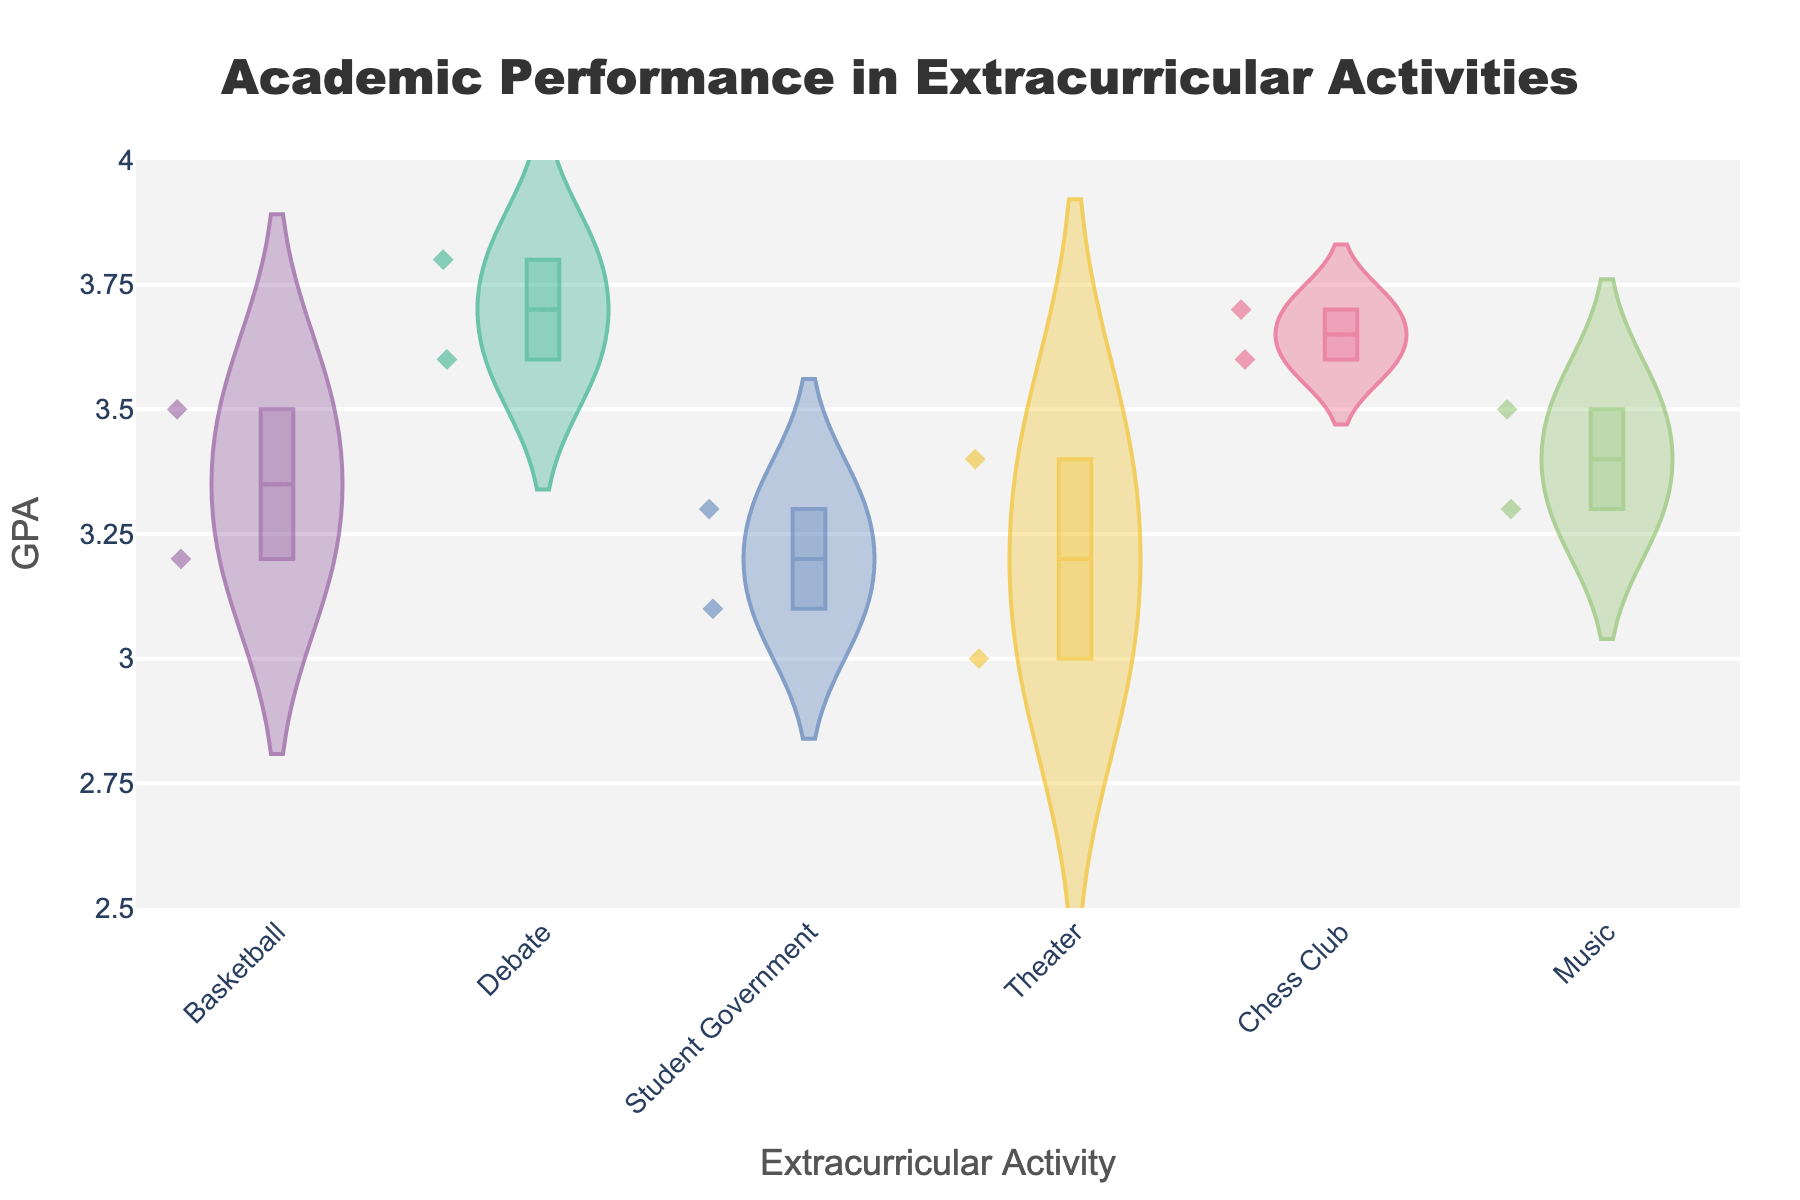What is the title of the figure? The title is typically placed at the top of the figure and provides a clear description of what the plot represents. Here, the title reads "Academic Performance in Extracurricular Activities".
Answer: Academic Performance in Extracurricular Activities What is the range of the y-axis? The y-axis usually represents the GPA values in the figure. The range is indicated by the lowest and highest tick marks on the axis, which here range from 2.5 to 4.0.
Answer: 2.5 to 4.0 How many different extracurricular activities are represented in the figure? Each activity forms a group in the violin plot. By counting the unique groups on the x-axis, we find there are six activities: Basketball, Debate, Student Government, Theater, Chess Club, and Music.
Answer: 6 Which extracurricular activity has the highest median GPA? The median GPA for each group is shown by a line within the box plot inside the violin plot. The activity with the highest median GPA is Debate.
Answer: Debate Which two extracurricular activities have the most similar spread in GPA values? The spread of GPA values can be observed by looking at the width and height of the violin plots. Student Government and Music show visually similar spreads because their violin plots are comparable in width and height.
Answer: Student Government, Music What is the approximate median GPA for Basketball? The median GPA is indicated by a line within the box plot overlaid on the violin plot. For Basketball, the median GPA is approximately 3.35.
Answer: 3.35 How do the GPA distributions differ between Theater and Chess Club? The distributions' differences can be observed from the shapes and densities of the violin plots. Theater's distribution appears more concentrated around the median with some spread, whereas Chess Club has a more uniform spread and a slightly higher concentration towards the top of the plot.
Answer: Theater: Concentrated around median, Chess Club: Uniform spread Which activity shows the widest range of GPA values? The range of GPA values can be determined by looking at the height of each violin plot. Student Government appears to have the widest range, as its violin plot spans from about 3.1 to 3.3.
Answer: Student Government What is the mean GPA for Debate, and how can it be inferred? The mean GPA for each violin plot is marked by a dashed line inside the box plot. For Debate, the mean GPA is approximately close to its median, around 3.70.
Answer: 3.70 